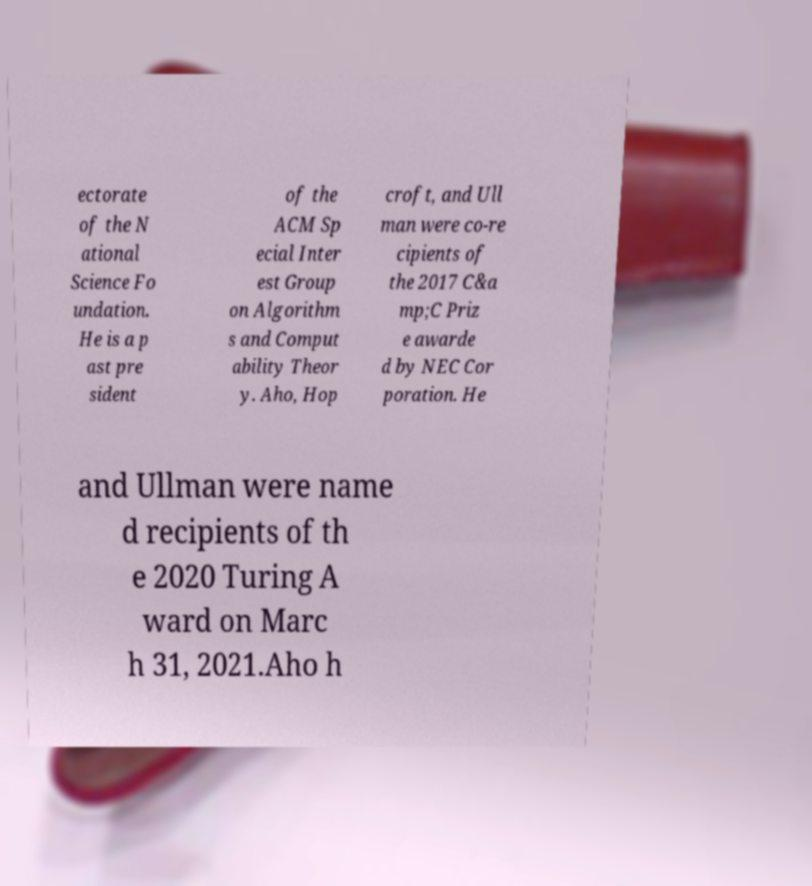Can you accurately transcribe the text from the provided image for me? ectorate of the N ational Science Fo undation. He is a p ast pre sident of the ACM Sp ecial Inter est Group on Algorithm s and Comput ability Theor y. Aho, Hop croft, and Ull man were co-re cipients of the 2017 C&a mp;C Priz e awarde d by NEC Cor poration. He and Ullman were name d recipients of th e 2020 Turing A ward on Marc h 31, 2021.Aho h 